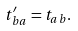<formula> <loc_0><loc_0><loc_500><loc_500>t _ { b a } ^ { \prime } = t _ { a b } .</formula> 